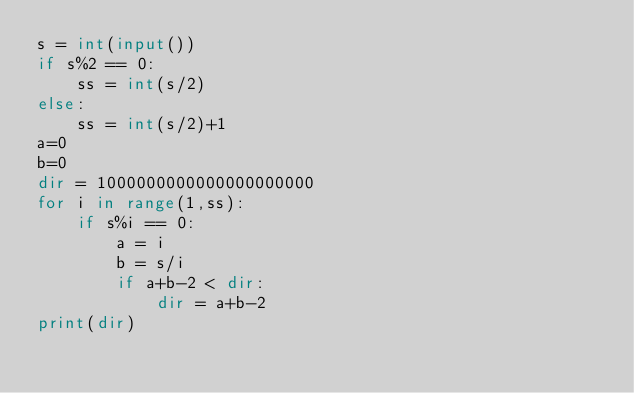Convert code to text. <code><loc_0><loc_0><loc_500><loc_500><_Python_>s = int(input())
if s%2 == 0:
	ss = int(s/2)
else:
	ss = int(s/2)+1
a=0
b=0
dir = 1000000000000000000000
for i in range(1,ss):
	if s%i == 0:
		a = i
		b = s/i
		if a+b-2 < dir:
			dir = a+b-2
print(dir)
</code> 